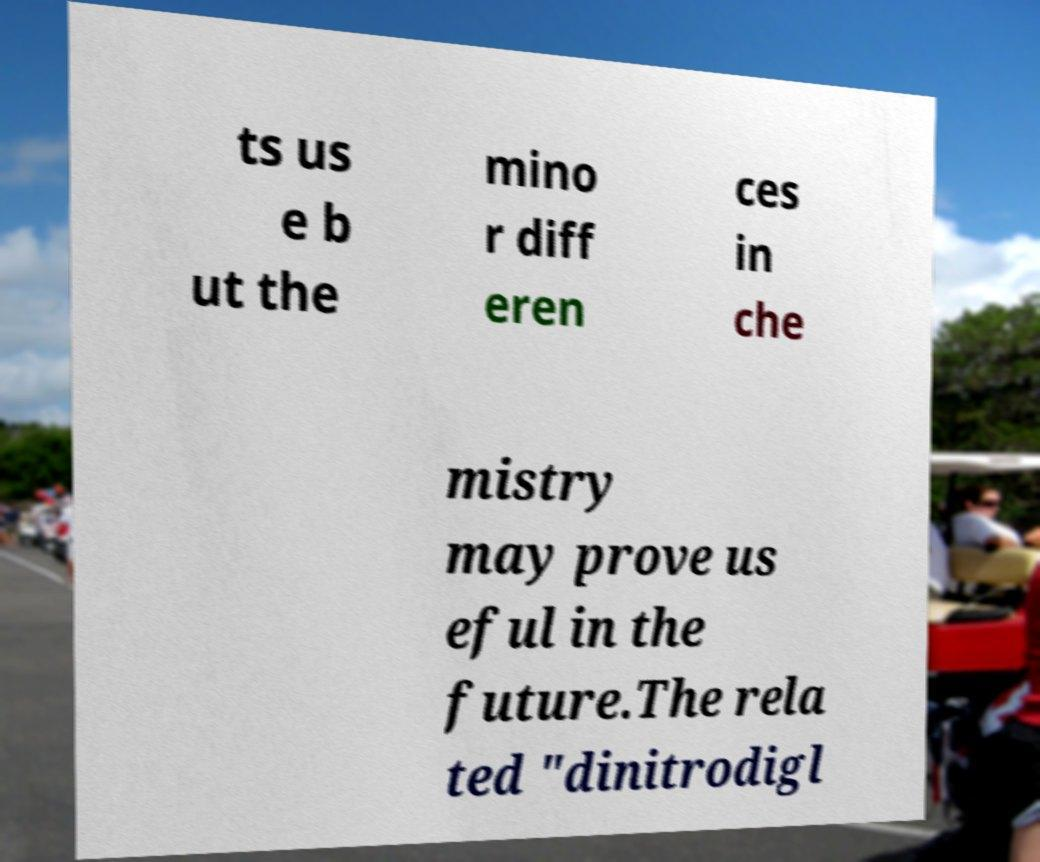I need the written content from this picture converted into text. Can you do that? ts us e b ut the mino r diff eren ces in che mistry may prove us eful in the future.The rela ted "dinitrodigl 